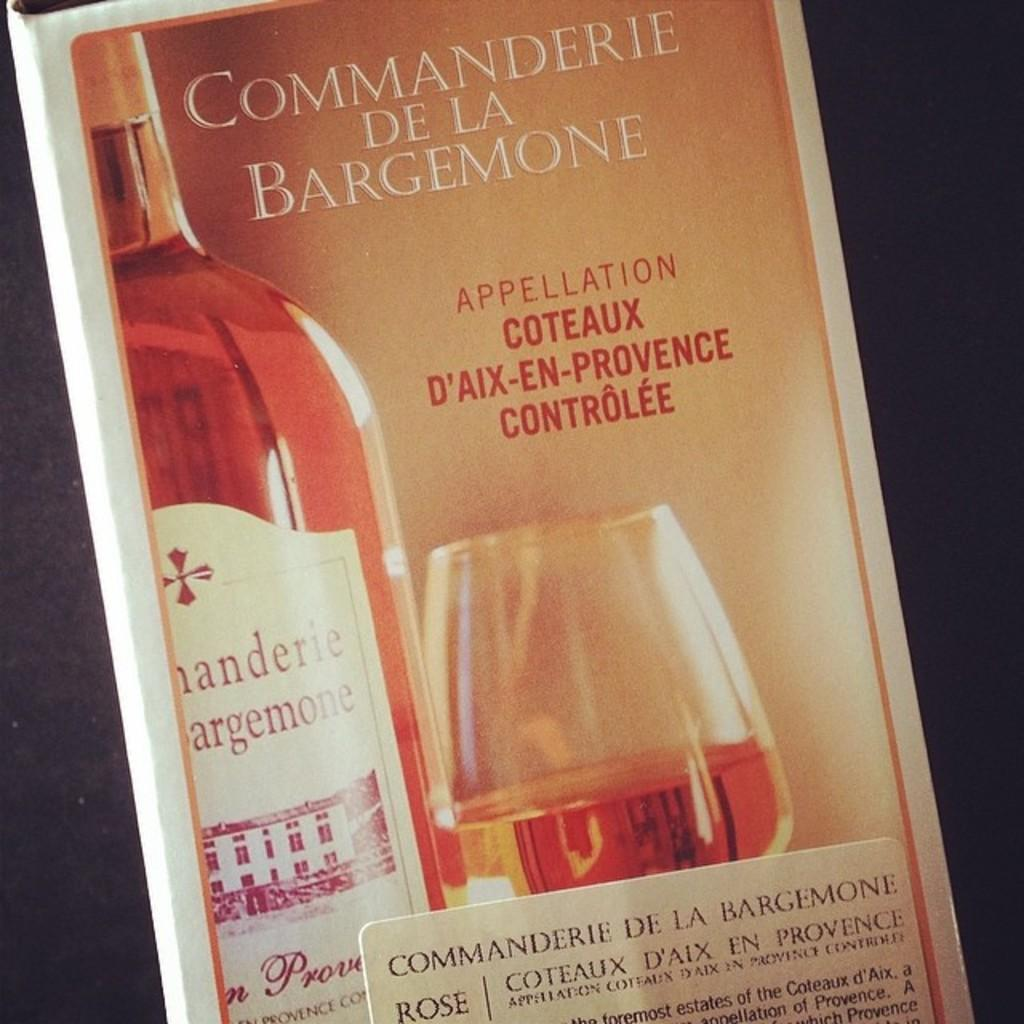<image>
Create a compact narrative representing the image presented. Poster advertising Commanderie de la Bargemone rose wine showing bottle of wine and product in wine glass. 